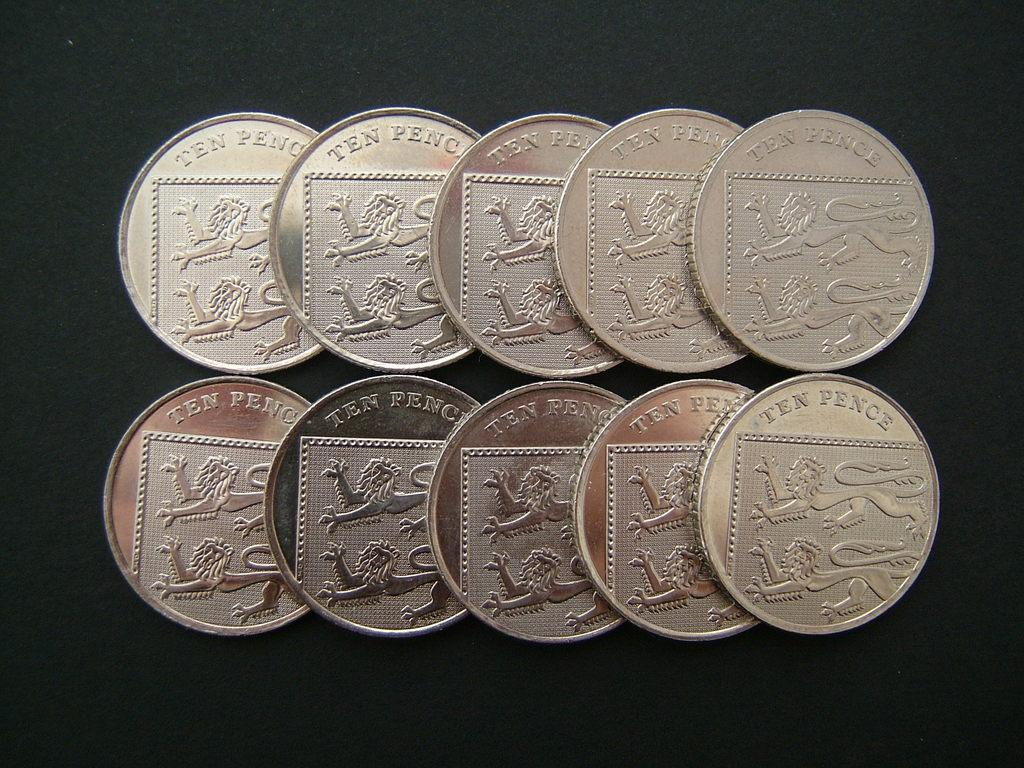<image>
Provide a brief description of the given image. A group of coin change with ten pence written on it. 